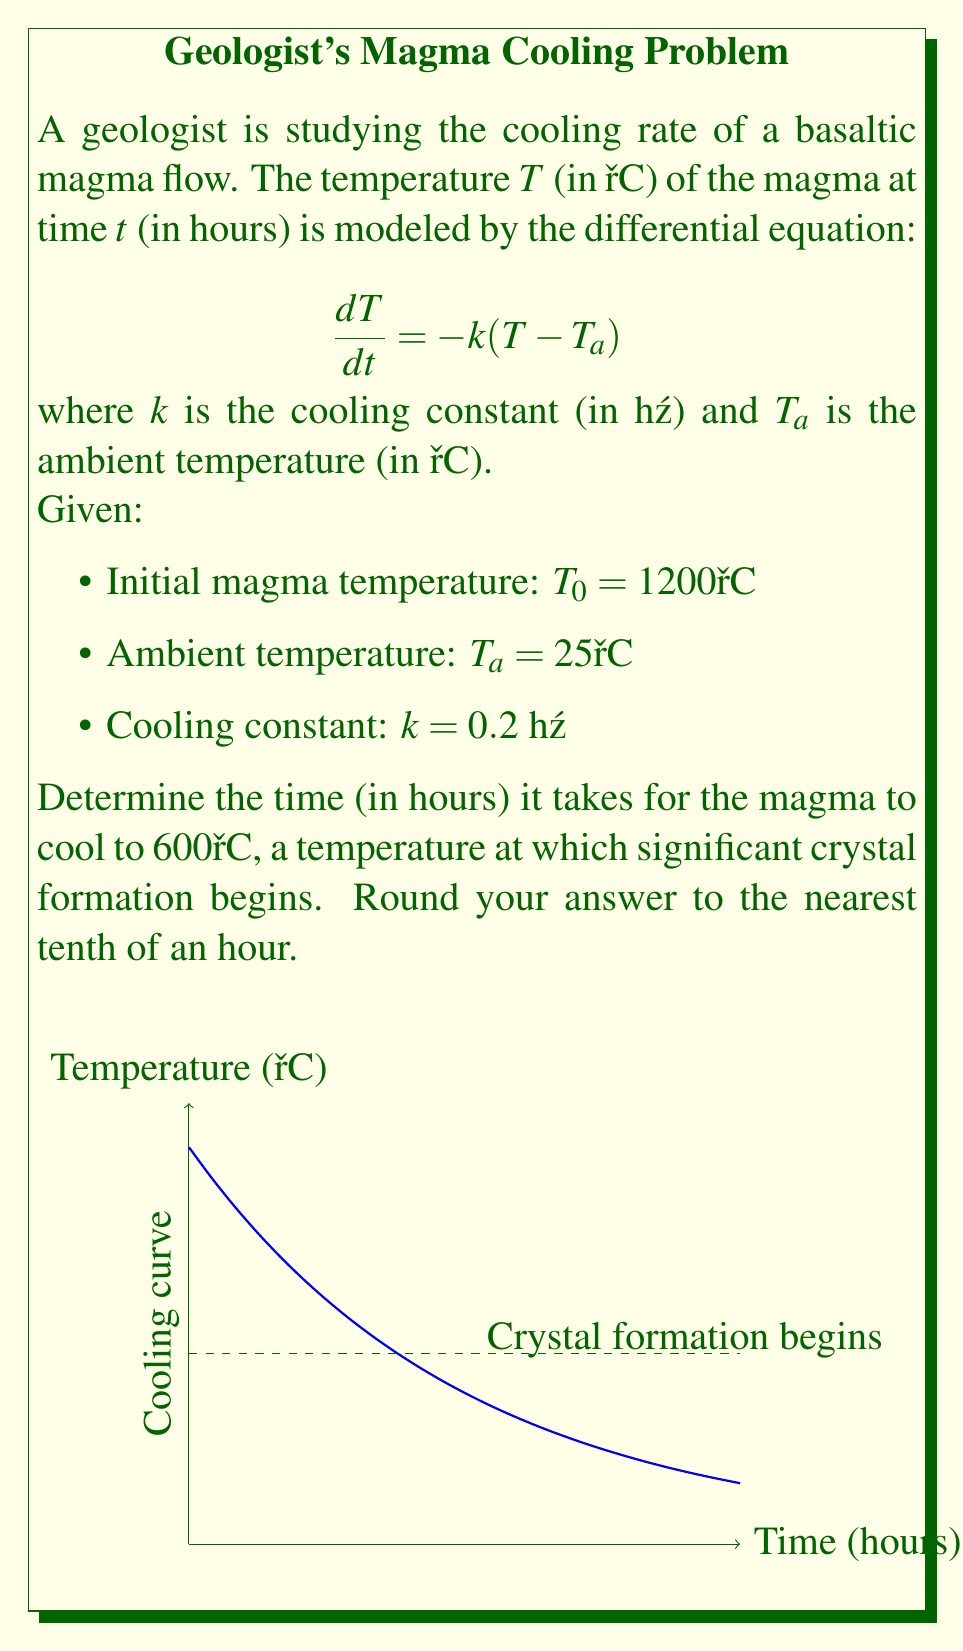Solve this math problem. To solve this problem, we need to follow these steps:

1) The general solution to the given differential equation is:
   $$T(t) = (T_0 - T_a)e^{-kt} + T_a$$

2) Substitute the given values:
   $$T(t) = (1200 - 25)e^{-0.2t} + 25$$
   $$T(t) = 1175e^{-0.2t} + 25$$

3) We want to find $t$ when $T(t) = 600°C$. So, let's set up the equation:
   $$600 = 1175e^{-0.2t} + 25$$

4) Subtract 25 from both sides:
   $$575 = 1175e^{-0.2t}$$

5) Divide both sides by 1175:
   $$\frac{575}{1175} = e^{-0.2t}$$

6) Take the natural logarithm of both sides:
   $$\ln(\frac{575}{1175}) = -0.2t$$

7) Divide both sides by -0.2:
   $$\frac{\ln(\frac{575}{1175})}{-0.2} = t$$

8) Calculate the result:
   $$t = \frac{\ln(0.4893617)}{-0.2} \approx 3.5741 \text{ hours}$$

9) Rounding to the nearest tenth:
   $$t \approx 3.6 \text{ hours}$$
Answer: 3.6 hours 